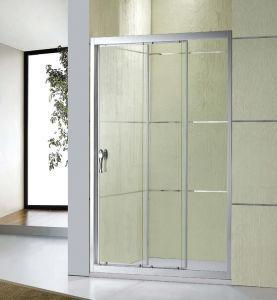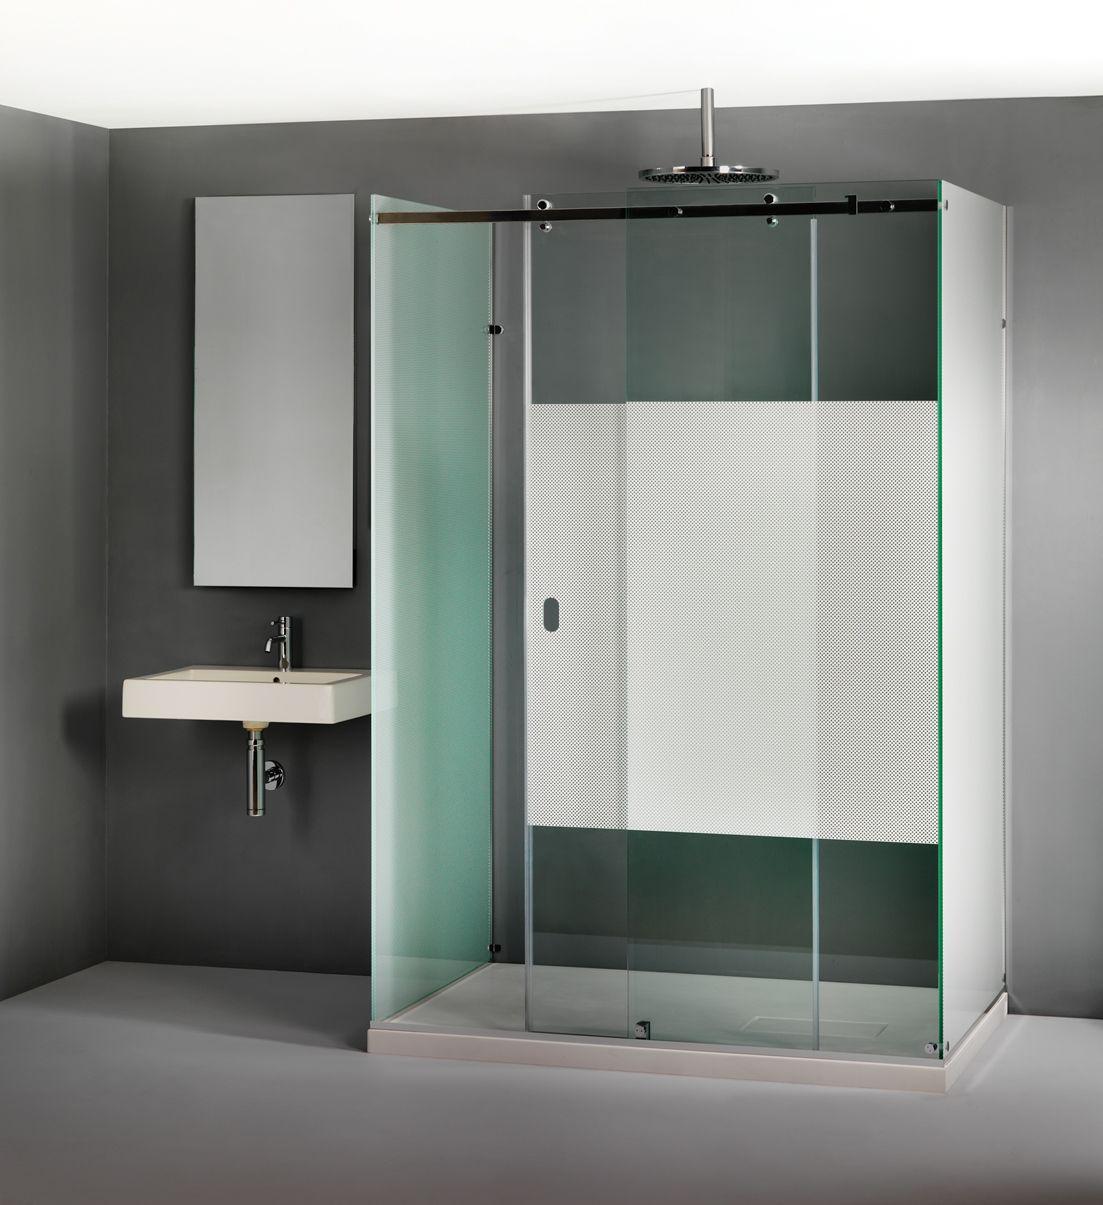The first image is the image on the left, the second image is the image on the right. Examine the images to the left and right. Is the description "In each room there are mirrored sliding doors on the closet." accurate? Answer yes or no. No. 